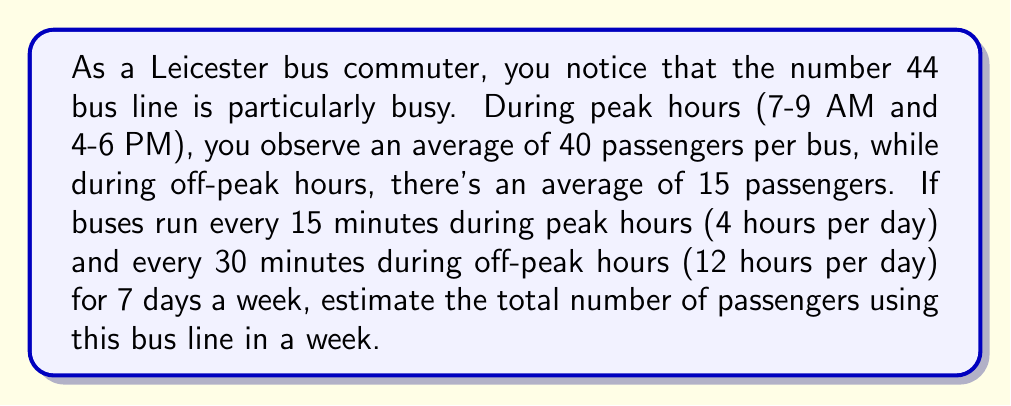Can you solve this math problem? Let's break this down step-by-step:

1. Calculate passengers during peak hours:
   - Peak hours per day: 4 hours
   - Buses per hour during peak: $60 \div 15 = 4$
   - Buses during peak hours per day: $4 \times 4 = 16$
   - Passengers per bus during peak: 40
   - Passengers during peak hours per day: $16 \times 40 = 640$

2. Calculate passengers during off-peak hours:
   - Off-peak hours per day: 12 hours
   - Buses per hour during off-peak: $60 \div 30 = 2$
   - Buses during off-peak hours per day: $12 \times 2 = 24$
   - Passengers per bus during off-peak: 15
   - Passengers during off-peak hours per day: $24 \times 15 = 360$

3. Total passengers per day:
   $\text{Total} = \text{Peak} + \text{Off-peak} = 640 + 360 = 1000$

4. Total passengers per week:
   $\text{Weekly total} = \text{Daily total} \times 7 \text{ days}$
   $\text{Weekly total} = 1000 \times 7 = 7000$

Therefore, we estimate that 7000 passengers use this bus line in a week.
Answer: 7000 passengers 